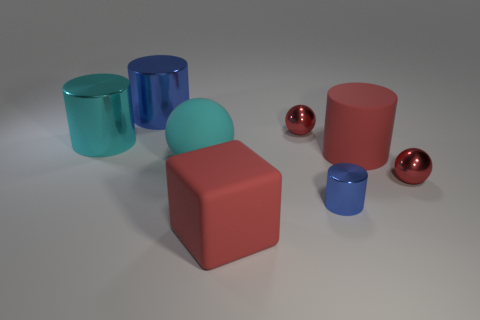Subtract all metallic cylinders. How many cylinders are left? 1 Add 2 tiny brown metallic objects. How many objects exist? 10 Subtract 1 blocks. How many blocks are left? 0 Subtract all cyan balls. How many balls are left? 2 Subtract 0 blue cubes. How many objects are left? 8 Subtract all spheres. How many objects are left? 5 Subtract all brown spheres. Subtract all blue cubes. How many spheres are left? 3 Subtract all gray cylinders. How many cyan spheres are left? 1 Subtract all big objects. Subtract all cyan rubber balls. How many objects are left? 2 Add 1 red cubes. How many red cubes are left? 2 